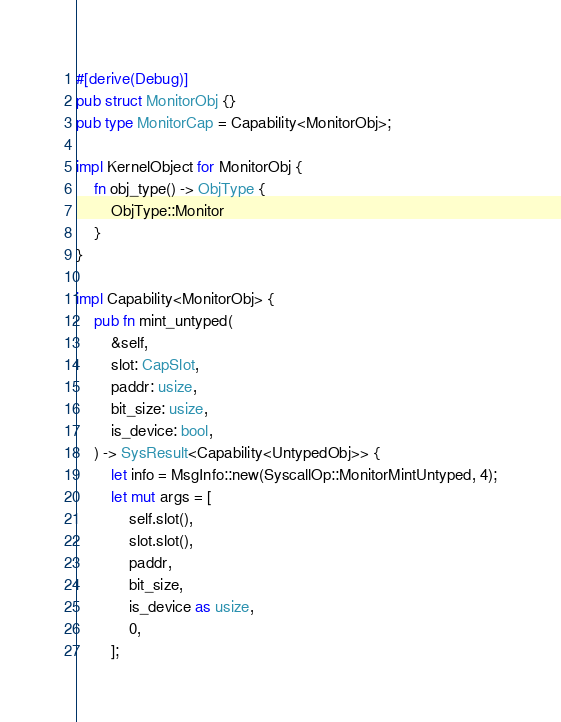Convert code to text. <code><loc_0><loc_0><loc_500><loc_500><_Rust_>#[derive(Debug)]
pub struct MonitorObj {}
pub type MonitorCap = Capability<MonitorObj>;

impl KernelObject for MonitorObj {
    fn obj_type() -> ObjType {
        ObjType::Monitor
    }
}

impl Capability<MonitorObj> {
    pub fn mint_untyped(
        &self,
        slot: CapSlot,
        paddr: usize,
        bit_size: usize,
        is_device: bool,
    ) -> SysResult<Capability<UntypedObj>> {
        let info = MsgInfo::new(SyscallOp::MonitorMintUntyped, 4);
        let mut args = [
            self.slot(),
            slot.slot(),
            paddr,
            bit_size,
            is_device as usize,
            0,
        ];</code> 